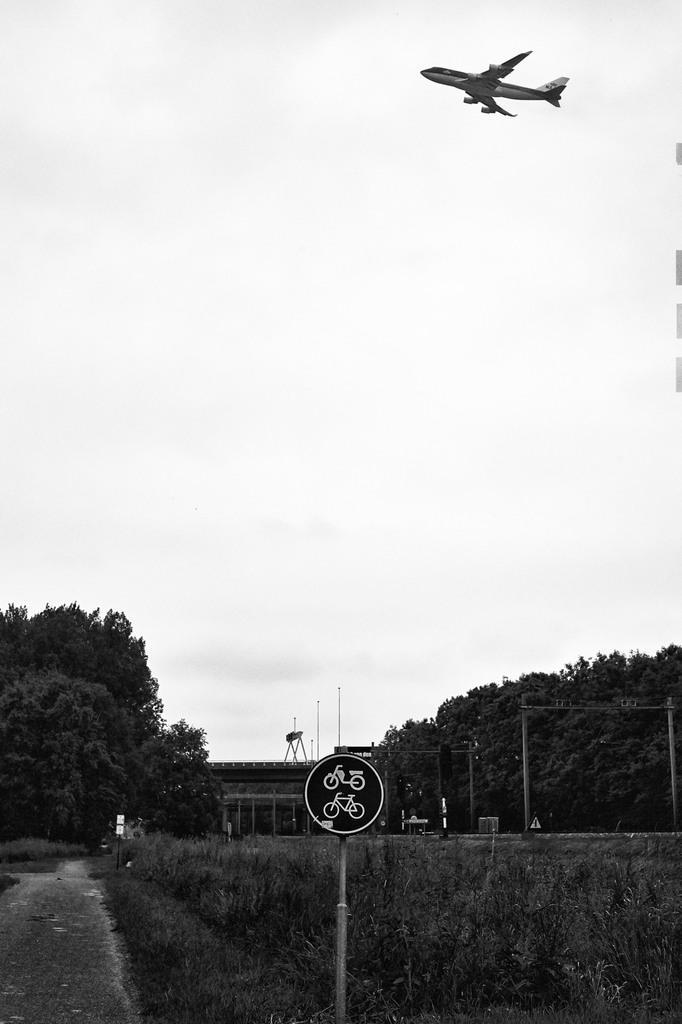In one or two sentences, can you explain what this image depicts? In this image I can see a board attached to the pole, background I can see trees, an aircraft and the sky is in white color. 